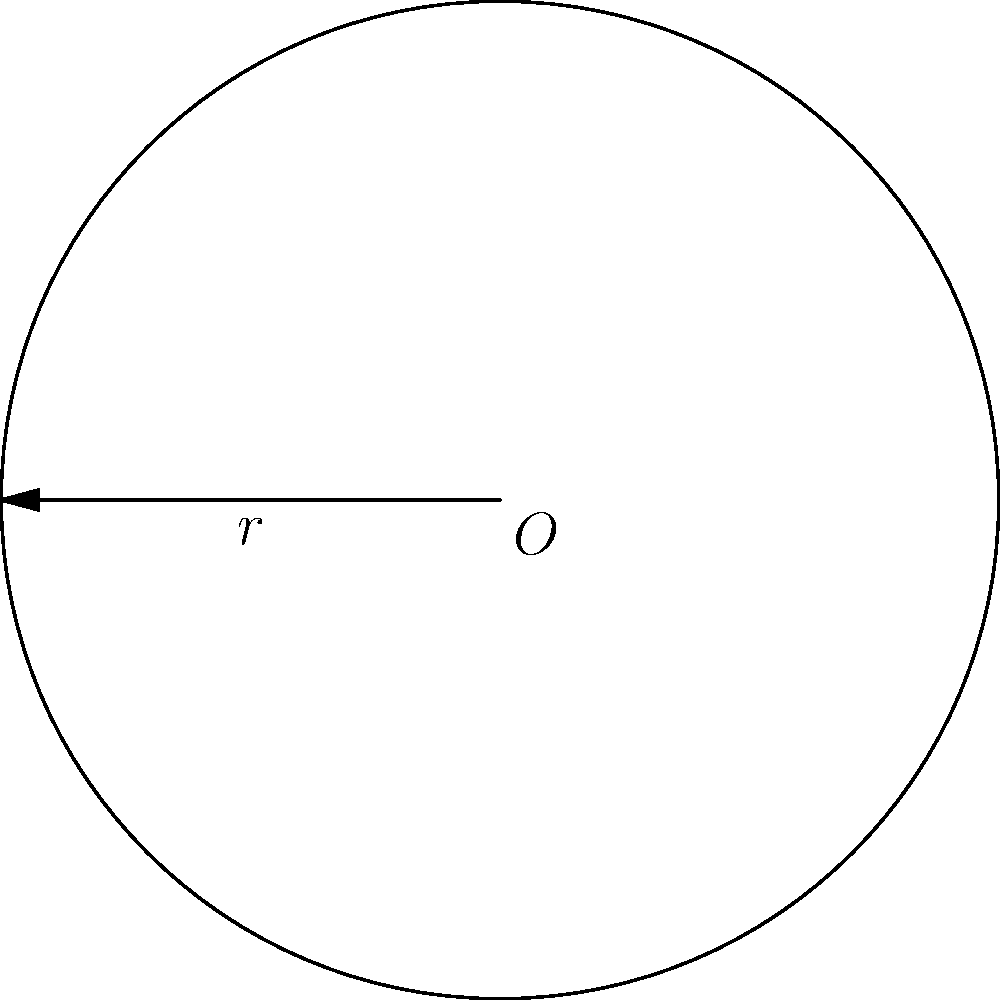As a seasoned blogger, you often use circular diagrams to illustrate concepts. In your latest post about basic geometry, you've drawn a circle with a radius of 5 units. What is the circumference of this circle? (Use $\pi \approx 3.14$ for your calculations) To find the circumference of a circle given its radius, we'll follow these steps:

1) Recall the formula for the circumference of a circle:
   $$C = 2\pi r$$
   where $C$ is the circumference, $\pi$ is pi, and $r$ is the radius.

2) We're given that the radius $r = 5$ units and we should use $\pi \approx 3.14$.

3) Let's substitute these values into our formula:
   $$C = 2 \times 3.14 \times 5$$

4) Now, let's calculate:
   $$C = 6.28 \times 5 = 31.4$$

5) Therefore, the circumference of the circle is 31.4 units.

This example demonstrates how a simple formula can be applied to real-world blogging scenarios, helping newcomers understand both the mathematical concept and its practical application.
Answer: 31.4 units 